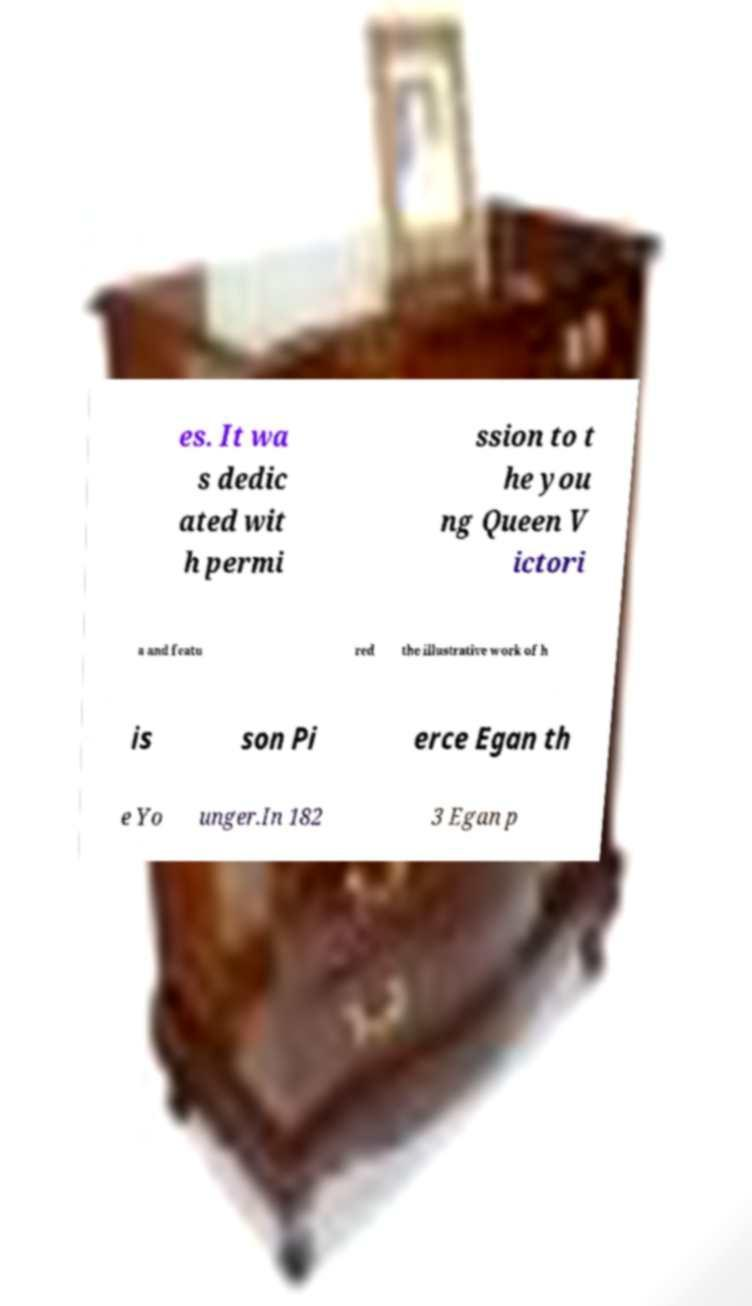For documentation purposes, I need the text within this image transcribed. Could you provide that? es. It wa s dedic ated wit h permi ssion to t he you ng Queen V ictori a and featu red the illustrative work of h is son Pi erce Egan th e Yo unger.In 182 3 Egan p 